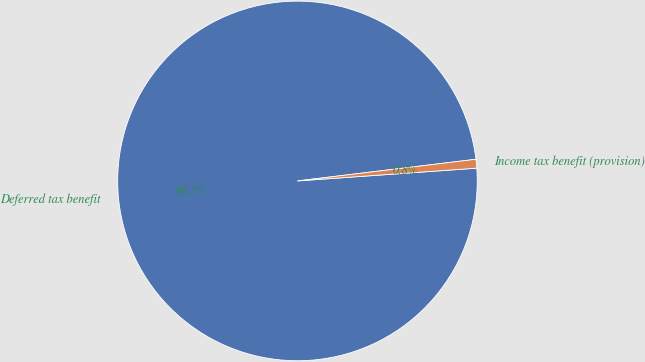<chart> <loc_0><loc_0><loc_500><loc_500><pie_chart><fcel>Deferred tax benefit<fcel>Income tax benefit (provision)<nl><fcel>99.21%<fcel>0.79%<nl></chart> 